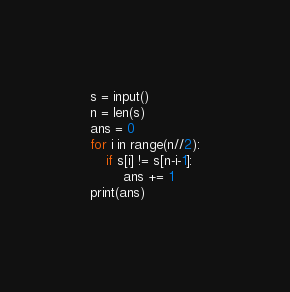Convert code to text. <code><loc_0><loc_0><loc_500><loc_500><_Python_>s = input()
n = len(s)
ans = 0
for i in range(n//2):
	if s[i] != s[n-i-1]:
		ans += 1
print(ans)
</code> 